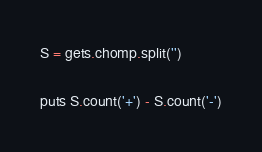<code> <loc_0><loc_0><loc_500><loc_500><_Ruby_>S = gets.chomp.split('')

puts S.count('+') - S.count('-')
</code> 